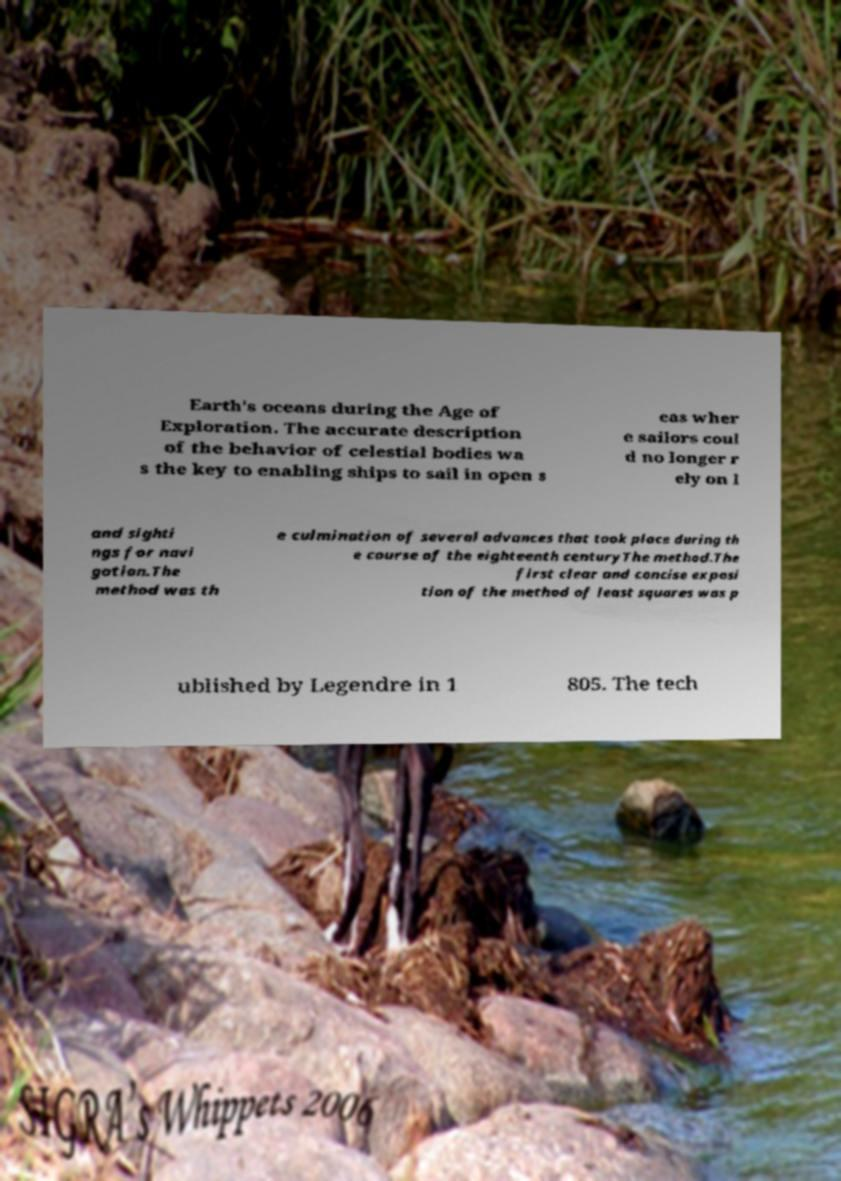Can you accurately transcribe the text from the provided image for me? Earth's oceans during the Age of Exploration. The accurate description of the behavior of celestial bodies wa s the key to enabling ships to sail in open s eas wher e sailors coul d no longer r ely on l and sighti ngs for navi gation.The method was th e culmination of several advances that took place during th e course of the eighteenth centuryThe method.The first clear and concise exposi tion of the method of least squares was p ublished by Legendre in 1 805. The tech 